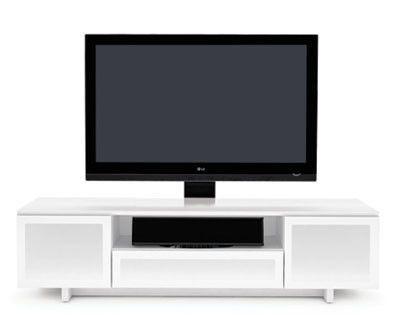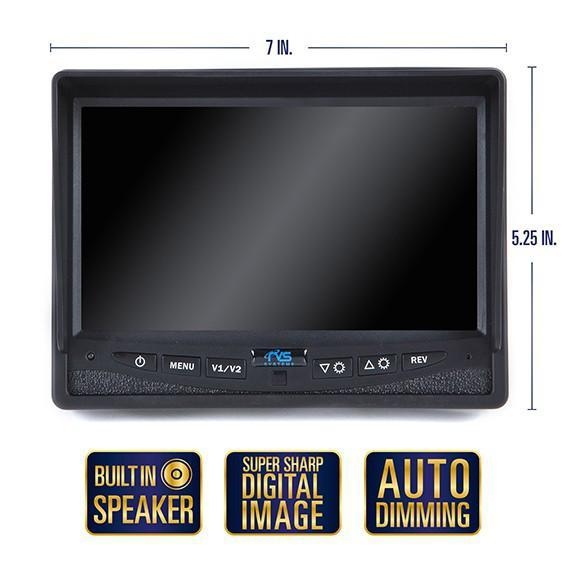The first image is the image on the left, the second image is the image on the right. Considering the images on both sides, is "One picture shows a TV above a piece of furniture." valid? Answer yes or no. Yes. The first image is the image on the left, the second image is the image on the right. Analyze the images presented: Is the assertion "Each image contains a rectangular gray-black screen that is displayed head-on instead of at an angle." valid? Answer yes or no. Yes. 